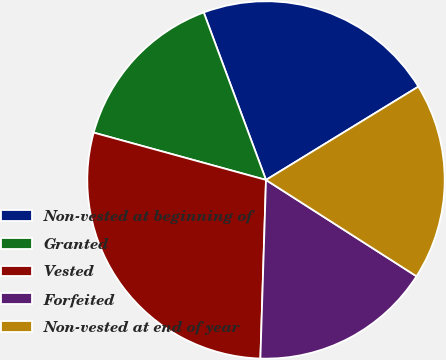Convert chart to OTSL. <chart><loc_0><loc_0><loc_500><loc_500><pie_chart><fcel>Non-vested at beginning of<fcel>Granted<fcel>Vested<fcel>Forfeited<fcel>Non-vested at end of year<nl><fcel>21.92%<fcel>15.07%<fcel>28.77%<fcel>16.44%<fcel>17.81%<nl></chart> 